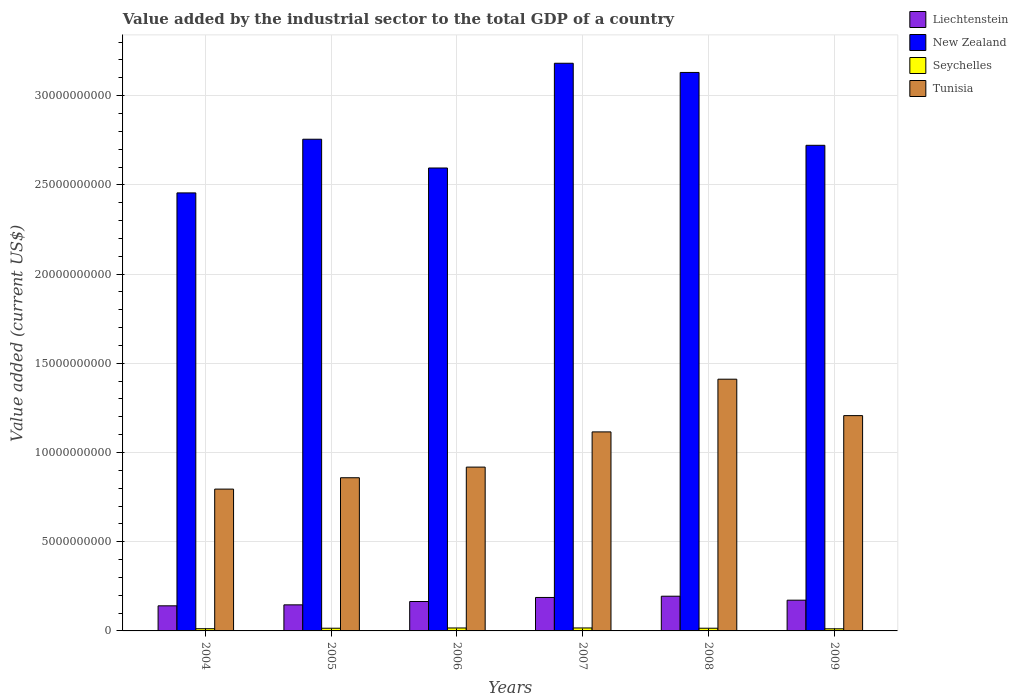How many different coloured bars are there?
Your answer should be compact. 4. Are the number of bars on each tick of the X-axis equal?
Offer a terse response. Yes. How many bars are there on the 6th tick from the left?
Provide a succinct answer. 4. How many bars are there on the 2nd tick from the right?
Provide a short and direct response. 4. What is the label of the 1st group of bars from the left?
Give a very brief answer. 2004. What is the value added by the industrial sector to the total GDP in Tunisia in 2006?
Provide a short and direct response. 9.18e+09. Across all years, what is the maximum value added by the industrial sector to the total GDP in New Zealand?
Your answer should be very brief. 3.18e+1. Across all years, what is the minimum value added by the industrial sector to the total GDP in Seychelles?
Make the answer very short. 1.19e+08. What is the total value added by the industrial sector to the total GDP in Tunisia in the graph?
Your answer should be compact. 6.30e+1. What is the difference between the value added by the industrial sector to the total GDP in Tunisia in 2004 and that in 2008?
Your response must be concise. -6.16e+09. What is the difference between the value added by the industrial sector to the total GDP in Seychelles in 2005 and the value added by the industrial sector to the total GDP in New Zealand in 2006?
Give a very brief answer. -2.58e+1. What is the average value added by the industrial sector to the total GDP in New Zealand per year?
Keep it short and to the point. 2.81e+1. In the year 2006, what is the difference between the value added by the industrial sector to the total GDP in Liechtenstein and value added by the industrial sector to the total GDP in Tunisia?
Keep it short and to the point. -7.53e+09. What is the ratio of the value added by the industrial sector to the total GDP in Seychelles in 2006 to that in 2008?
Offer a very short reply. 1.09. Is the value added by the industrial sector to the total GDP in Seychelles in 2004 less than that in 2007?
Provide a short and direct response. Yes. What is the difference between the highest and the second highest value added by the industrial sector to the total GDP in Seychelles?
Make the answer very short. 1.17e+06. What is the difference between the highest and the lowest value added by the industrial sector to the total GDP in Tunisia?
Ensure brevity in your answer.  6.16e+09. What does the 4th bar from the left in 2004 represents?
Give a very brief answer. Tunisia. What does the 3rd bar from the right in 2005 represents?
Provide a short and direct response. New Zealand. Is it the case that in every year, the sum of the value added by the industrial sector to the total GDP in Liechtenstein and value added by the industrial sector to the total GDP in New Zealand is greater than the value added by the industrial sector to the total GDP in Seychelles?
Offer a terse response. Yes. How many years are there in the graph?
Offer a very short reply. 6. What is the difference between two consecutive major ticks on the Y-axis?
Provide a succinct answer. 5.00e+09. Are the values on the major ticks of Y-axis written in scientific E-notation?
Give a very brief answer. No. What is the title of the graph?
Ensure brevity in your answer.  Value added by the industrial sector to the total GDP of a country. What is the label or title of the Y-axis?
Ensure brevity in your answer.  Value added (current US$). What is the Value added (current US$) in Liechtenstein in 2004?
Your answer should be compact. 1.41e+09. What is the Value added (current US$) of New Zealand in 2004?
Ensure brevity in your answer.  2.45e+1. What is the Value added (current US$) of Seychelles in 2004?
Offer a very short reply. 1.24e+08. What is the Value added (current US$) in Tunisia in 2004?
Provide a succinct answer. 7.95e+09. What is the Value added (current US$) in Liechtenstein in 2005?
Give a very brief answer. 1.46e+09. What is the Value added (current US$) of New Zealand in 2005?
Your response must be concise. 2.76e+1. What is the Value added (current US$) of Seychelles in 2005?
Offer a very short reply. 1.51e+08. What is the Value added (current US$) in Tunisia in 2005?
Your answer should be very brief. 8.59e+09. What is the Value added (current US$) in Liechtenstein in 2006?
Make the answer very short. 1.65e+09. What is the Value added (current US$) of New Zealand in 2006?
Make the answer very short. 2.59e+1. What is the Value added (current US$) of Seychelles in 2006?
Your answer should be compact. 1.65e+08. What is the Value added (current US$) in Tunisia in 2006?
Give a very brief answer. 9.18e+09. What is the Value added (current US$) in Liechtenstein in 2007?
Your answer should be very brief. 1.88e+09. What is the Value added (current US$) of New Zealand in 2007?
Your answer should be compact. 3.18e+1. What is the Value added (current US$) in Seychelles in 2007?
Keep it short and to the point. 1.66e+08. What is the Value added (current US$) in Tunisia in 2007?
Your response must be concise. 1.12e+1. What is the Value added (current US$) in Liechtenstein in 2008?
Provide a succinct answer. 1.95e+09. What is the Value added (current US$) of New Zealand in 2008?
Give a very brief answer. 3.13e+1. What is the Value added (current US$) of Seychelles in 2008?
Keep it short and to the point. 1.51e+08. What is the Value added (current US$) of Tunisia in 2008?
Your response must be concise. 1.41e+1. What is the Value added (current US$) of Liechtenstein in 2009?
Provide a succinct answer. 1.72e+09. What is the Value added (current US$) in New Zealand in 2009?
Keep it short and to the point. 2.72e+1. What is the Value added (current US$) in Seychelles in 2009?
Offer a terse response. 1.19e+08. What is the Value added (current US$) in Tunisia in 2009?
Keep it short and to the point. 1.21e+1. Across all years, what is the maximum Value added (current US$) in Liechtenstein?
Provide a succinct answer. 1.95e+09. Across all years, what is the maximum Value added (current US$) in New Zealand?
Your answer should be compact. 3.18e+1. Across all years, what is the maximum Value added (current US$) in Seychelles?
Offer a terse response. 1.66e+08. Across all years, what is the maximum Value added (current US$) of Tunisia?
Make the answer very short. 1.41e+1. Across all years, what is the minimum Value added (current US$) in Liechtenstein?
Ensure brevity in your answer.  1.41e+09. Across all years, what is the minimum Value added (current US$) in New Zealand?
Keep it short and to the point. 2.45e+1. Across all years, what is the minimum Value added (current US$) in Seychelles?
Your answer should be very brief. 1.19e+08. Across all years, what is the minimum Value added (current US$) in Tunisia?
Provide a succinct answer. 7.95e+09. What is the total Value added (current US$) in Liechtenstein in the graph?
Give a very brief answer. 1.01e+1. What is the total Value added (current US$) of New Zealand in the graph?
Make the answer very short. 1.68e+11. What is the total Value added (current US$) of Seychelles in the graph?
Offer a very short reply. 8.76e+08. What is the total Value added (current US$) of Tunisia in the graph?
Give a very brief answer. 6.30e+1. What is the difference between the Value added (current US$) in Liechtenstein in 2004 and that in 2005?
Offer a very short reply. -5.46e+07. What is the difference between the Value added (current US$) in New Zealand in 2004 and that in 2005?
Give a very brief answer. -3.01e+09. What is the difference between the Value added (current US$) of Seychelles in 2004 and that in 2005?
Ensure brevity in your answer.  -2.65e+07. What is the difference between the Value added (current US$) of Tunisia in 2004 and that in 2005?
Offer a very short reply. -6.36e+08. What is the difference between the Value added (current US$) in Liechtenstein in 2004 and that in 2006?
Offer a terse response. -2.42e+08. What is the difference between the Value added (current US$) of New Zealand in 2004 and that in 2006?
Your answer should be compact. -1.40e+09. What is the difference between the Value added (current US$) in Seychelles in 2004 and that in 2006?
Your response must be concise. -4.09e+07. What is the difference between the Value added (current US$) in Tunisia in 2004 and that in 2006?
Your response must be concise. -1.23e+09. What is the difference between the Value added (current US$) of Liechtenstein in 2004 and that in 2007?
Offer a terse response. -4.69e+08. What is the difference between the Value added (current US$) of New Zealand in 2004 and that in 2007?
Ensure brevity in your answer.  -7.27e+09. What is the difference between the Value added (current US$) in Seychelles in 2004 and that in 2007?
Offer a terse response. -4.21e+07. What is the difference between the Value added (current US$) in Tunisia in 2004 and that in 2007?
Offer a terse response. -3.21e+09. What is the difference between the Value added (current US$) of Liechtenstein in 2004 and that in 2008?
Provide a succinct answer. -5.39e+08. What is the difference between the Value added (current US$) of New Zealand in 2004 and that in 2008?
Your answer should be very brief. -6.75e+09. What is the difference between the Value added (current US$) in Seychelles in 2004 and that in 2008?
Provide a succinct answer. -2.70e+07. What is the difference between the Value added (current US$) in Tunisia in 2004 and that in 2008?
Keep it short and to the point. -6.16e+09. What is the difference between the Value added (current US$) of Liechtenstein in 2004 and that in 2009?
Keep it short and to the point. -3.17e+08. What is the difference between the Value added (current US$) of New Zealand in 2004 and that in 2009?
Keep it short and to the point. -2.67e+09. What is the difference between the Value added (current US$) of Seychelles in 2004 and that in 2009?
Keep it short and to the point. 5.28e+06. What is the difference between the Value added (current US$) of Tunisia in 2004 and that in 2009?
Offer a very short reply. -4.12e+09. What is the difference between the Value added (current US$) in Liechtenstein in 2005 and that in 2006?
Your answer should be compact. -1.87e+08. What is the difference between the Value added (current US$) of New Zealand in 2005 and that in 2006?
Offer a very short reply. 1.61e+09. What is the difference between the Value added (current US$) of Seychelles in 2005 and that in 2006?
Your response must be concise. -1.43e+07. What is the difference between the Value added (current US$) of Tunisia in 2005 and that in 2006?
Provide a short and direct response. -5.96e+08. What is the difference between the Value added (current US$) of Liechtenstein in 2005 and that in 2007?
Give a very brief answer. -4.14e+08. What is the difference between the Value added (current US$) of New Zealand in 2005 and that in 2007?
Keep it short and to the point. -4.26e+09. What is the difference between the Value added (current US$) in Seychelles in 2005 and that in 2007?
Your response must be concise. -1.55e+07. What is the difference between the Value added (current US$) in Tunisia in 2005 and that in 2007?
Your answer should be compact. -2.57e+09. What is the difference between the Value added (current US$) of Liechtenstein in 2005 and that in 2008?
Your answer should be compact. -4.85e+08. What is the difference between the Value added (current US$) in New Zealand in 2005 and that in 2008?
Keep it short and to the point. -3.74e+09. What is the difference between the Value added (current US$) of Seychelles in 2005 and that in 2008?
Make the answer very short. -4.83e+05. What is the difference between the Value added (current US$) in Tunisia in 2005 and that in 2008?
Your answer should be very brief. -5.52e+09. What is the difference between the Value added (current US$) in Liechtenstein in 2005 and that in 2009?
Your response must be concise. -2.62e+08. What is the difference between the Value added (current US$) of New Zealand in 2005 and that in 2009?
Keep it short and to the point. 3.41e+08. What is the difference between the Value added (current US$) of Seychelles in 2005 and that in 2009?
Provide a succinct answer. 3.18e+07. What is the difference between the Value added (current US$) of Tunisia in 2005 and that in 2009?
Ensure brevity in your answer.  -3.48e+09. What is the difference between the Value added (current US$) of Liechtenstein in 2006 and that in 2007?
Offer a terse response. -2.27e+08. What is the difference between the Value added (current US$) in New Zealand in 2006 and that in 2007?
Give a very brief answer. -5.87e+09. What is the difference between the Value added (current US$) in Seychelles in 2006 and that in 2007?
Your answer should be very brief. -1.17e+06. What is the difference between the Value added (current US$) of Tunisia in 2006 and that in 2007?
Your response must be concise. -1.97e+09. What is the difference between the Value added (current US$) of Liechtenstein in 2006 and that in 2008?
Provide a succinct answer. -2.97e+08. What is the difference between the Value added (current US$) of New Zealand in 2006 and that in 2008?
Provide a short and direct response. -5.36e+09. What is the difference between the Value added (current US$) of Seychelles in 2006 and that in 2008?
Keep it short and to the point. 1.39e+07. What is the difference between the Value added (current US$) of Tunisia in 2006 and that in 2008?
Provide a succinct answer. -4.93e+09. What is the difference between the Value added (current US$) in Liechtenstein in 2006 and that in 2009?
Keep it short and to the point. -7.45e+07. What is the difference between the Value added (current US$) in New Zealand in 2006 and that in 2009?
Provide a short and direct response. -1.27e+09. What is the difference between the Value added (current US$) of Seychelles in 2006 and that in 2009?
Give a very brief answer. 4.62e+07. What is the difference between the Value added (current US$) of Tunisia in 2006 and that in 2009?
Keep it short and to the point. -2.89e+09. What is the difference between the Value added (current US$) in Liechtenstein in 2007 and that in 2008?
Provide a short and direct response. -7.07e+07. What is the difference between the Value added (current US$) in New Zealand in 2007 and that in 2008?
Ensure brevity in your answer.  5.15e+08. What is the difference between the Value added (current US$) in Seychelles in 2007 and that in 2008?
Your answer should be compact. 1.50e+07. What is the difference between the Value added (current US$) of Tunisia in 2007 and that in 2008?
Provide a short and direct response. -2.95e+09. What is the difference between the Value added (current US$) in Liechtenstein in 2007 and that in 2009?
Ensure brevity in your answer.  1.52e+08. What is the difference between the Value added (current US$) of New Zealand in 2007 and that in 2009?
Offer a terse response. 4.60e+09. What is the difference between the Value added (current US$) of Seychelles in 2007 and that in 2009?
Your answer should be compact. 4.73e+07. What is the difference between the Value added (current US$) in Tunisia in 2007 and that in 2009?
Offer a terse response. -9.13e+08. What is the difference between the Value added (current US$) of Liechtenstein in 2008 and that in 2009?
Your answer should be compact. 2.23e+08. What is the difference between the Value added (current US$) of New Zealand in 2008 and that in 2009?
Your answer should be compact. 4.08e+09. What is the difference between the Value added (current US$) in Seychelles in 2008 and that in 2009?
Your answer should be compact. 3.23e+07. What is the difference between the Value added (current US$) of Tunisia in 2008 and that in 2009?
Make the answer very short. 2.04e+09. What is the difference between the Value added (current US$) of Liechtenstein in 2004 and the Value added (current US$) of New Zealand in 2005?
Give a very brief answer. -2.62e+1. What is the difference between the Value added (current US$) of Liechtenstein in 2004 and the Value added (current US$) of Seychelles in 2005?
Make the answer very short. 1.26e+09. What is the difference between the Value added (current US$) of Liechtenstein in 2004 and the Value added (current US$) of Tunisia in 2005?
Make the answer very short. -7.18e+09. What is the difference between the Value added (current US$) in New Zealand in 2004 and the Value added (current US$) in Seychelles in 2005?
Ensure brevity in your answer.  2.44e+1. What is the difference between the Value added (current US$) in New Zealand in 2004 and the Value added (current US$) in Tunisia in 2005?
Provide a short and direct response. 1.60e+1. What is the difference between the Value added (current US$) in Seychelles in 2004 and the Value added (current US$) in Tunisia in 2005?
Your answer should be very brief. -8.46e+09. What is the difference between the Value added (current US$) of Liechtenstein in 2004 and the Value added (current US$) of New Zealand in 2006?
Give a very brief answer. -2.45e+1. What is the difference between the Value added (current US$) of Liechtenstein in 2004 and the Value added (current US$) of Seychelles in 2006?
Give a very brief answer. 1.24e+09. What is the difference between the Value added (current US$) in Liechtenstein in 2004 and the Value added (current US$) in Tunisia in 2006?
Offer a terse response. -7.77e+09. What is the difference between the Value added (current US$) of New Zealand in 2004 and the Value added (current US$) of Seychelles in 2006?
Offer a very short reply. 2.44e+1. What is the difference between the Value added (current US$) in New Zealand in 2004 and the Value added (current US$) in Tunisia in 2006?
Make the answer very short. 1.54e+1. What is the difference between the Value added (current US$) in Seychelles in 2004 and the Value added (current US$) in Tunisia in 2006?
Give a very brief answer. -9.06e+09. What is the difference between the Value added (current US$) in Liechtenstein in 2004 and the Value added (current US$) in New Zealand in 2007?
Offer a very short reply. -3.04e+1. What is the difference between the Value added (current US$) of Liechtenstein in 2004 and the Value added (current US$) of Seychelles in 2007?
Give a very brief answer. 1.24e+09. What is the difference between the Value added (current US$) of Liechtenstein in 2004 and the Value added (current US$) of Tunisia in 2007?
Keep it short and to the point. -9.75e+09. What is the difference between the Value added (current US$) in New Zealand in 2004 and the Value added (current US$) in Seychelles in 2007?
Provide a succinct answer. 2.44e+1. What is the difference between the Value added (current US$) in New Zealand in 2004 and the Value added (current US$) in Tunisia in 2007?
Provide a short and direct response. 1.34e+1. What is the difference between the Value added (current US$) in Seychelles in 2004 and the Value added (current US$) in Tunisia in 2007?
Ensure brevity in your answer.  -1.10e+1. What is the difference between the Value added (current US$) of Liechtenstein in 2004 and the Value added (current US$) of New Zealand in 2008?
Ensure brevity in your answer.  -2.99e+1. What is the difference between the Value added (current US$) of Liechtenstein in 2004 and the Value added (current US$) of Seychelles in 2008?
Provide a short and direct response. 1.26e+09. What is the difference between the Value added (current US$) in Liechtenstein in 2004 and the Value added (current US$) in Tunisia in 2008?
Keep it short and to the point. -1.27e+1. What is the difference between the Value added (current US$) in New Zealand in 2004 and the Value added (current US$) in Seychelles in 2008?
Make the answer very short. 2.44e+1. What is the difference between the Value added (current US$) in New Zealand in 2004 and the Value added (current US$) in Tunisia in 2008?
Provide a short and direct response. 1.04e+1. What is the difference between the Value added (current US$) of Seychelles in 2004 and the Value added (current US$) of Tunisia in 2008?
Your answer should be very brief. -1.40e+1. What is the difference between the Value added (current US$) of Liechtenstein in 2004 and the Value added (current US$) of New Zealand in 2009?
Give a very brief answer. -2.58e+1. What is the difference between the Value added (current US$) in Liechtenstein in 2004 and the Value added (current US$) in Seychelles in 2009?
Your answer should be compact. 1.29e+09. What is the difference between the Value added (current US$) in Liechtenstein in 2004 and the Value added (current US$) in Tunisia in 2009?
Ensure brevity in your answer.  -1.07e+1. What is the difference between the Value added (current US$) of New Zealand in 2004 and the Value added (current US$) of Seychelles in 2009?
Ensure brevity in your answer.  2.44e+1. What is the difference between the Value added (current US$) of New Zealand in 2004 and the Value added (current US$) of Tunisia in 2009?
Your answer should be very brief. 1.25e+1. What is the difference between the Value added (current US$) in Seychelles in 2004 and the Value added (current US$) in Tunisia in 2009?
Keep it short and to the point. -1.19e+1. What is the difference between the Value added (current US$) in Liechtenstein in 2005 and the Value added (current US$) in New Zealand in 2006?
Your answer should be compact. -2.45e+1. What is the difference between the Value added (current US$) of Liechtenstein in 2005 and the Value added (current US$) of Seychelles in 2006?
Your answer should be very brief. 1.30e+09. What is the difference between the Value added (current US$) of Liechtenstein in 2005 and the Value added (current US$) of Tunisia in 2006?
Ensure brevity in your answer.  -7.72e+09. What is the difference between the Value added (current US$) in New Zealand in 2005 and the Value added (current US$) in Seychelles in 2006?
Give a very brief answer. 2.74e+1. What is the difference between the Value added (current US$) of New Zealand in 2005 and the Value added (current US$) of Tunisia in 2006?
Make the answer very short. 1.84e+1. What is the difference between the Value added (current US$) of Seychelles in 2005 and the Value added (current US$) of Tunisia in 2006?
Your response must be concise. -9.03e+09. What is the difference between the Value added (current US$) in Liechtenstein in 2005 and the Value added (current US$) in New Zealand in 2007?
Your response must be concise. -3.04e+1. What is the difference between the Value added (current US$) in Liechtenstein in 2005 and the Value added (current US$) in Seychelles in 2007?
Your answer should be very brief. 1.29e+09. What is the difference between the Value added (current US$) in Liechtenstein in 2005 and the Value added (current US$) in Tunisia in 2007?
Make the answer very short. -9.69e+09. What is the difference between the Value added (current US$) in New Zealand in 2005 and the Value added (current US$) in Seychelles in 2007?
Offer a very short reply. 2.74e+1. What is the difference between the Value added (current US$) in New Zealand in 2005 and the Value added (current US$) in Tunisia in 2007?
Your answer should be compact. 1.64e+1. What is the difference between the Value added (current US$) in Seychelles in 2005 and the Value added (current US$) in Tunisia in 2007?
Make the answer very short. -1.10e+1. What is the difference between the Value added (current US$) in Liechtenstein in 2005 and the Value added (current US$) in New Zealand in 2008?
Make the answer very short. -2.98e+1. What is the difference between the Value added (current US$) of Liechtenstein in 2005 and the Value added (current US$) of Seychelles in 2008?
Keep it short and to the point. 1.31e+09. What is the difference between the Value added (current US$) in Liechtenstein in 2005 and the Value added (current US$) in Tunisia in 2008?
Offer a very short reply. -1.26e+1. What is the difference between the Value added (current US$) in New Zealand in 2005 and the Value added (current US$) in Seychelles in 2008?
Give a very brief answer. 2.74e+1. What is the difference between the Value added (current US$) of New Zealand in 2005 and the Value added (current US$) of Tunisia in 2008?
Offer a terse response. 1.34e+1. What is the difference between the Value added (current US$) of Seychelles in 2005 and the Value added (current US$) of Tunisia in 2008?
Make the answer very short. -1.40e+1. What is the difference between the Value added (current US$) of Liechtenstein in 2005 and the Value added (current US$) of New Zealand in 2009?
Your response must be concise. -2.58e+1. What is the difference between the Value added (current US$) of Liechtenstein in 2005 and the Value added (current US$) of Seychelles in 2009?
Offer a very short reply. 1.34e+09. What is the difference between the Value added (current US$) of Liechtenstein in 2005 and the Value added (current US$) of Tunisia in 2009?
Your answer should be very brief. -1.06e+1. What is the difference between the Value added (current US$) of New Zealand in 2005 and the Value added (current US$) of Seychelles in 2009?
Your response must be concise. 2.74e+1. What is the difference between the Value added (current US$) of New Zealand in 2005 and the Value added (current US$) of Tunisia in 2009?
Your response must be concise. 1.55e+1. What is the difference between the Value added (current US$) in Seychelles in 2005 and the Value added (current US$) in Tunisia in 2009?
Offer a terse response. -1.19e+1. What is the difference between the Value added (current US$) in Liechtenstein in 2006 and the Value added (current US$) in New Zealand in 2007?
Give a very brief answer. -3.02e+1. What is the difference between the Value added (current US$) of Liechtenstein in 2006 and the Value added (current US$) of Seychelles in 2007?
Offer a very short reply. 1.48e+09. What is the difference between the Value added (current US$) in Liechtenstein in 2006 and the Value added (current US$) in Tunisia in 2007?
Your answer should be compact. -9.51e+09. What is the difference between the Value added (current US$) of New Zealand in 2006 and the Value added (current US$) of Seychelles in 2007?
Your answer should be very brief. 2.58e+1. What is the difference between the Value added (current US$) in New Zealand in 2006 and the Value added (current US$) in Tunisia in 2007?
Offer a very short reply. 1.48e+1. What is the difference between the Value added (current US$) in Seychelles in 2006 and the Value added (current US$) in Tunisia in 2007?
Make the answer very short. -1.10e+1. What is the difference between the Value added (current US$) in Liechtenstein in 2006 and the Value added (current US$) in New Zealand in 2008?
Make the answer very short. -2.97e+1. What is the difference between the Value added (current US$) in Liechtenstein in 2006 and the Value added (current US$) in Seychelles in 2008?
Offer a terse response. 1.50e+09. What is the difference between the Value added (current US$) in Liechtenstein in 2006 and the Value added (current US$) in Tunisia in 2008?
Your answer should be very brief. -1.25e+1. What is the difference between the Value added (current US$) of New Zealand in 2006 and the Value added (current US$) of Seychelles in 2008?
Your answer should be very brief. 2.58e+1. What is the difference between the Value added (current US$) in New Zealand in 2006 and the Value added (current US$) in Tunisia in 2008?
Keep it short and to the point. 1.18e+1. What is the difference between the Value added (current US$) in Seychelles in 2006 and the Value added (current US$) in Tunisia in 2008?
Offer a very short reply. -1.39e+1. What is the difference between the Value added (current US$) in Liechtenstein in 2006 and the Value added (current US$) in New Zealand in 2009?
Ensure brevity in your answer.  -2.56e+1. What is the difference between the Value added (current US$) of Liechtenstein in 2006 and the Value added (current US$) of Seychelles in 2009?
Provide a succinct answer. 1.53e+09. What is the difference between the Value added (current US$) in Liechtenstein in 2006 and the Value added (current US$) in Tunisia in 2009?
Make the answer very short. -1.04e+1. What is the difference between the Value added (current US$) of New Zealand in 2006 and the Value added (current US$) of Seychelles in 2009?
Ensure brevity in your answer.  2.58e+1. What is the difference between the Value added (current US$) in New Zealand in 2006 and the Value added (current US$) in Tunisia in 2009?
Offer a very short reply. 1.39e+1. What is the difference between the Value added (current US$) in Seychelles in 2006 and the Value added (current US$) in Tunisia in 2009?
Your response must be concise. -1.19e+1. What is the difference between the Value added (current US$) of Liechtenstein in 2007 and the Value added (current US$) of New Zealand in 2008?
Keep it short and to the point. -2.94e+1. What is the difference between the Value added (current US$) of Liechtenstein in 2007 and the Value added (current US$) of Seychelles in 2008?
Offer a terse response. 1.72e+09. What is the difference between the Value added (current US$) in Liechtenstein in 2007 and the Value added (current US$) in Tunisia in 2008?
Ensure brevity in your answer.  -1.22e+1. What is the difference between the Value added (current US$) of New Zealand in 2007 and the Value added (current US$) of Seychelles in 2008?
Make the answer very short. 3.17e+1. What is the difference between the Value added (current US$) in New Zealand in 2007 and the Value added (current US$) in Tunisia in 2008?
Make the answer very short. 1.77e+1. What is the difference between the Value added (current US$) of Seychelles in 2007 and the Value added (current US$) of Tunisia in 2008?
Give a very brief answer. -1.39e+1. What is the difference between the Value added (current US$) in Liechtenstein in 2007 and the Value added (current US$) in New Zealand in 2009?
Provide a succinct answer. -2.53e+1. What is the difference between the Value added (current US$) in Liechtenstein in 2007 and the Value added (current US$) in Seychelles in 2009?
Keep it short and to the point. 1.76e+09. What is the difference between the Value added (current US$) in Liechtenstein in 2007 and the Value added (current US$) in Tunisia in 2009?
Your answer should be very brief. -1.02e+1. What is the difference between the Value added (current US$) of New Zealand in 2007 and the Value added (current US$) of Seychelles in 2009?
Give a very brief answer. 3.17e+1. What is the difference between the Value added (current US$) in New Zealand in 2007 and the Value added (current US$) in Tunisia in 2009?
Your answer should be compact. 1.97e+1. What is the difference between the Value added (current US$) in Seychelles in 2007 and the Value added (current US$) in Tunisia in 2009?
Make the answer very short. -1.19e+1. What is the difference between the Value added (current US$) of Liechtenstein in 2008 and the Value added (current US$) of New Zealand in 2009?
Give a very brief answer. -2.53e+1. What is the difference between the Value added (current US$) in Liechtenstein in 2008 and the Value added (current US$) in Seychelles in 2009?
Give a very brief answer. 1.83e+09. What is the difference between the Value added (current US$) of Liechtenstein in 2008 and the Value added (current US$) of Tunisia in 2009?
Give a very brief answer. -1.01e+1. What is the difference between the Value added (current US$) of New Zealand in 2008 and the Value added (current US$) of Seychelles in 2009?
Your response must be concise. 3.12e+1. What is the difference between the Value added (current US$) of New Zealand in 2008 and the Value added (current US$) of Tunisia in 2009?
Your answer should be very brief. 1.92e+1. What is the difference between the Value added (current US$) of Seychelles in 2008 and the Value added (current US$) of Tunisia in 2009?
Provide a short and direct response. -1.19e+1. What is the average Value added (current US$) of Liechtenstein per year?
Provide a short and direct response. 1.68e+09. What is the average Value added (current US$) of New Zealand per year?
Ensure brevity in your answer.  2.81e+1. What is the average Value added (current US$) in Seychelles per year?
Provide a succinct answer. 1.46e+08. What is the average Value added (current US$) in Tunisia per year?
Your answer should be very brief. 1.05e+1. In the year 2004, what is the difference between the Value added (current US$) in Liechtenstein and Value added (current US$) in New Zealand?
Provide a succinct answer. -2.31e+1. In the year 2004, what is the difference between the Value added (current US$) of Liechtenstein and Value added (current US$) of Seychelles?
Keep it short and to the point. 1.28e+09. In the year 2004, what is the difference between the Value added (current US$) of Liechtenstein and Value added (current US$) of Tunisia?
Keep it short and to the point. -6.54e+09. In the year 2004, what is the difference between the Value added (current US$) of New Zealand and Value added (current US$) of Seychelles?
Offer a very short reply. 2.44e+1. In the year 2004, what is the difference between the Value added (current US$) of New Zealand and Value added (current US$) of Tunisia?
Ensure brevity in your answer.  1.66e+1. In the year 2004, what is the difference between the Value added (current US$) in Seychelles and Value added (current US$) in Tunisia?
Provide a short and direct response. -7.82e+09. In the year 2005, what is the difference between the Value added (current US$) in Liechtenstein and Value added (current US$) in New Zealand?
Make the answer very short. -2.61e+1. In the year 2005, what is the difference between the Value added (current US$) of Liechtenstein and Value added (current US$) of Seychelles?
Your answer should be compact. 1.31e+09. In the year 2005, what is the difference between the Value added (current US$) of Liechtenstein and Value added (current US$) of Tunisia?
Keep it short and to the point. -7.12e+09. In the year 2005, what is the difference between the Value added (current US$) of New Zealand and Value added (current US$) of Seychelles?
Give a very brief answer. 2.74e+1. In the year 2005, what is the difference between the Value added (current US$) in New Zealand and Value added (current US$) in Tunisia?
Ensure brevity in your answer.  1.90e+1. In the year 2005, what is the difference between the Value added (current US$) of Seychelles and Value added (current US$) of Tunisia?
Keep it short and to the point. -8.43e+09. In the year 2006, what is the difference between the Value added (current US$) in Liechtenstein and Value added (current US$) in New Zealand?
Offer a very short reply. -2.43e+1. In the year 2006, what is the difference between the Value added (current US$) in Liechtenstein and Value added (current US$) in Seychelles?
Provide a succinct answer. 1.48e+09. In the year 2006, what is the difference between the Value added (current US$) of Liechtenstein and Value added (current US$) of Tunisia?
Your response must be concise. -7.53e+09. In the year 2006, what is the difference between the Value added (current US$) of New Zealand and Value added (current US$) of Seychelles?
Give a very brief answer. 2.58e+1. In the year 2006, what is the difference between the Value added (current US$) in New Zealand and Value added (current US$) in Tunisia?
Your answer should be very brief. 1.68e+1. In the year 2006, what is the difference between the Value added (current US$) in Seychelles and Value added (current US$) in Tunisia?
Keep it short and to the point. -9.02e+09. In the year 2007, what is the difference between the Value added (current US$) of Liechtenstein and Value added (current US$) of New Zealand?
Offer a terse response. -2.99e+1. In the year 2007, what is the difference between the Value added (current US$) in Liechtenstein and Value added (current US$) in Seychelles?
Your answer should be compact. 1.71e+09. In the year 2007, what is the difference between the Value added (current US$) of Liechtenstein and Value added (current US$) of Tunisia?
Make the answer very short. -9.28e+09. In the year 2007, what is the difference between the Value added (current US$) in New Zealand and Value added (current US$) in Seychelles?
Offer a very short reply. 3.17e+1. In the year 2007, what is the difference between the Value added (current US$) of New Zealand and Value added (current US$) of Tunisia?
Your response must be concise. 2.07e+1. In the year 2007, what is the difference between the Value added (current US$) of Seychelles and Value added (current US$) of Tunisia?
Provide a short and direct response. -1.10e+1. In the year 2008, what is the difference between the Value added (current US$) of Liechtenstein and Value added (current US$) of New Zealand?
Your response must be concise. -2.94e+1. In the year 2008, what is the difference between the Value added (current US$) in Liechtenstein and Value added (current US$) in Seychelles?
Ensure brevity in your answer.  1.79e+09. In the year 2008, what is the difference between the Value added (current US$) of Liechtenstein and Value added (current US$) of Tunisia?
Your answer should be very brief. -1.22e+1. In the year 2008, what is the difference between the Value added (current US$) in New Zealand and Value added (current US$) in Seychelles?
Make the answer very short. 3.12e+1. In the year 2008, what is the difference between the Value added (current US$) of New Zealand and Value added (current US$) of Tunisia?
Offer a terse response. 1.72e+1. In the year 2008, what is the difference between the Value added (current US$) in Seychelles and Value added (current US$) in Tunisia?
Your answer should be very brief. -1.40e+1. In the year 2009, what is the difference between the Value added (current US$) in Liechtenstein and Value added (current US$) in New Zealand?
Keep it short and to the point. -2.55e+1. In the year 2009, what is the difference between the Value added (current US$) of Liechtenstein and Value added (current US$) of Seychelles?
Provide a succinct answer. 1.60e+09. In the year 2009, what is the difference between the Value added (current US$) in Liechtenstein and Value added (current US$) in Tunisia?
Make the answer very short. -1.03e+1. In the year 2009, what is the difference between the Value added (current US$) of New Zealand and Value added (current US$) of Seychelles?
Your answer should be very brief. 2.71e+1. In the year 2009, what is the difference between the Value added (current US$) of New Zealand and Value added (current US$) of Tunisia?
Make the answer very short. 1.52e+1. In the year 2009, what is the difference between the Value added (current US$) of Seychelles and Value added (current US$) of Tunisia?
Ensure brevity in your answer.  -1.19e+1. What is the ratio of the Value added (current US$) in Liechtenstein in 2004 to that in 2005?
Offer a terse response. 0.96. What is the ratio of the Value added (current US$) of New Zealand in 2004 to that in 2005?
Your response must be concise. 0.89. What is the ratio of the Value added (current US$) of Seychelles in 2004 to that in 2005?
Give a very brief answer. 0.82. What is the ratio of the Value added (current US$) of Tunisia in 2004 to that in 2005?
Ensure brevity in your answer.  0.93. What is the ratio of the Value added (current US$) of Liechtenstein in 2004 to that in 2006?
Your response must be concise. 0.85. What is the ratio of the Value added (current US$) of New Zealand in 2004 to that in 2006?
Your answer should be very brief. 0.95. What is the ratio of the Value added (current US$) of Seychelles in 2004 to that in 2006?
Your response must be concise. 0.75. What is the ratio of the Value added (current US$) in Tunisia in 2004 to that in 2006?
Your response must be concise. 0.87. What is the ratio of the Value added (current US$) of Liechtenstein in 2004 to that in 2007?
Your response must be concise. 0.75. What is the ratio of the Value added (current US$) of New Zealand in 2004 to that in 2007?
Offer a terse response. 0.77. What is the ratio of the Value added (current US$) of Seychelles in 2004 to that in 2007?
Provide a short and direct response. 0.75. What is the ratio of the Value added (current US$) in Tunisia in 2004 to that in 2007?
Ensure brevity in your answer.  0.71. What is the ratio of the Value added (current US$) of Liechtenstein in 2004 to that in 2008?
Make the answer very short. 0.72. What is the ratio of the Value added (current US$) in New Zealand in 2004 to that in 2008?
Provide a short and direct response. 0.78. What is the ratio of the Value added (current US$) in Seychelles in 2004 to that in 2008?
Your answer should be compact. 0.82. What is the ratio of the Value added (current US$) of Tunisia in 2004 to that in 2008?
Offer a terse response. 0.56. What is the ratio of the Value added (current US$) of Liechtenstein in 2004 to that in 2009?
Make the answer very short. 0.82. What is the ratio of the Value added (current US$) in New Zealand in 2004 to that in 2009?
Give a very brief answer. 0.9. What is the ratio of the Value added (current US$) in Seychelles in 2004 to that in 2009?
Provide a succinct answer. 1.04. What is the ratio of the Value added (current US$) in Tunisia in 2004 to that in 2009?
Ensure brevity in your answer.  0.66. What is the ratio of the Value added (current US$) in Liechtenstein in 2005 to that in 2006?
Provide a succinct answer. 0.89. What is the ratio of the Value added (current US$) of New Zealand in 2005 to that in 2006?
Make the answer very short. 1.06. What is the ratio of the Value added (current US$) of Seychelles in 2005 to that in 2006?
Give a very brief answer. 0.91. What is the ratio of the Value added (current US$) in Tunisia in 2005 to that in 2006?
Your response must be concise. 0.94. What is the ratio of the Value added (current US$) in Liechtenstein in 2005 to that in 2007?
Keep it short and to the point. 0.78. What is the ratio of the Value added (current US$) in New Zealand in 2005 to that in 2007?
Your answer should be compact. 0.87. What is the ratio of the Value added (current US$) of Seychelles in 2005 to that in 2007?
Your answer should be compact. 0.91. What is the ratio of the Value added (current US$) in Tunisia in 2005 to that in 2007?
Provide a short and direct response. 0.77. What is the ratio of the Value added (current US$) in Liechtenstein in 2005 to that in 2008?
Keep it short and to the point. 0.75. What is the ratio of the Value added (current US$) in New Zealand in 2005 to that in 2008?
Keep it short and to the point. 0.88. What is the ratio of the Value added (current US$) of Tunisia in 2005 to that in 2008?
Provide a succinct answer. 0.61. What is the ratio of the Value added (current US$) in Liechtenstein in 2005 to that in 2009?
Offer a very short reply. 0.85. What is the ratio of the Value added (current US$) of New Zealand in 2005 to that in 2009?
Offer a very short reply. 1.01. What is the ratio of the Value added (current US$) of Seychelles in 2005 to that in 2009?
Ensure brevity in your answer.  1.27. What is the ratio of the Value added (current US$) in Tunisia in 2005 to that in 2009?
Your answer should be compact. 0.71. What is the ratio of the Value added (current US$) in Liechtenstein in 2006 to that in 2007?
Provide a short and direct response. 0.88. What is the ratio of the Value added (current US$) in New Zealand in 2006 to that in 2007?
Your answer should be very brief. 0.82. What is the ratio of the Value added (current US$) of Seychelles in 2006 to that in 2007?
Your answer should be compact. 0.99. What is the ratio of the Value added (current US$) in Tunisia in 2006 to that in 2007?
Provide a succinct answer. 0.82. What is the ratio of the Value added (current US$) in Liechtenstein in 2006 to that in 2008?
Offer a terse response. 0.85. What is the ratio of the Value added (current US$) of New Zealand in 2006 to that in 2008?
Your answer should be compact. 0.83. What is the ratio of the Value added (current US$) in Seychelles in 2006 to that in 2008?
Your answer should be compact. 1.09. What is the ratio of the Value added (current US$) of Tunisia in 2006 to that in 2008?
Provide a succinct answer. 0.65. What is the ratio of the Value added (current US$) in Liechtenstein in 2006 to that in 2009?
Keep it short and to the point. 0.96. What is the ratio of the Value added (current US$) of New Zealand in 2006 to that in 2009?
Your answer should be very brief. 0.95. What is the ratio of the Value added (current US$) in Seychelles in 2006 to that in 2009?
Your response must be concise. 1.39. What is the ratio of the Value added (current US$) of Tunisia in 2006 to that in 2009?
Provide a succinct answer. 0.76. What is the ratio of the Value added (current US$) in Liechtenstein in 2007 to that in 2008?
Provide a succinct answer. 0.96. What is the ratio of the Value added (current US$) in New Zealand in 2007 to that in 2008?
Provide a short and direct response. 1.02. What is the ratio of the Value added (current US$) in Seychelles in 2007 to that in 2008?
Ensure brevity in your answer.  1.1. What is the ratio of the Value added (current US$) in Tunisia in 2007 to that in 2008?
Provide a succinct answer. 0.79. What is the ratio of the Value added (current US$) in Liechtenstein in 2007 to that in 2009?
Your response must be concise. 1.09. What is the ratio of the Value added (current US$) of New Zealand in 2007 to that in 2009?
Your answer should be very brief. 1.17. What is the ratio of the Value added (current US$) of Seychelles in 2007 to that in 2009?
Offer a very short reply. 1.4. What is the ratio of the Value added (current US$) in Tunisia in 2007 to that in 2009?
Offer a very short reply. 0.92. What is the ratio of the Value added (current US$) in Liechtenstein in 2008 to that in 2009?
Give a very brief answer. 1.13. What is the ratio of the Value added (current US$) in New Zealand in 2008 to that in 2009?
Provide a short and direct response. 1.15. What is the ratio of the Value added (current US$) in Seychelles in 2008 to that in 2009?
Make the answer very short. 1.27. What is the ratio of the Value added (current US$) of Tunisia in 2008 to that in 2009?
Provide a short and direct response. 1.17. What is the difference between the highest and the second highest Value added (current US$) in Liechtenstein?
Offer a very short reply. 7.07e+07. What is the difference between the highest and the second highest Value added (current US$) of New Zealand?
Give a very brief answer. 5.15e+08. What is the difference between the highest and the second highest Value added (current US$) in Seychelles?
Your answer should be compact. 1.17e+06. What is the difference between the highest and the second highest Value added (current US$) in Tunisia?
Offer a terse response. 2.04e+09. What is the difference between the highest and the lowest Value added (current US$) of Liechtenstein?
Ensure brevity in your answer.  5.39e+08. What is the difference between the highest and the lowest Value added (current US$) of New Zealand?
Your answer should be very brief. 7.27e+09. What is the difference between the highest and the lowest Value added (current US$) in Seychelles?
Your response must be concise. 4.73e+07. What is the difference between the highest and the lowest Value added (current US$) of Tunisia?
Offer a very short reply. 6.16e+09. 